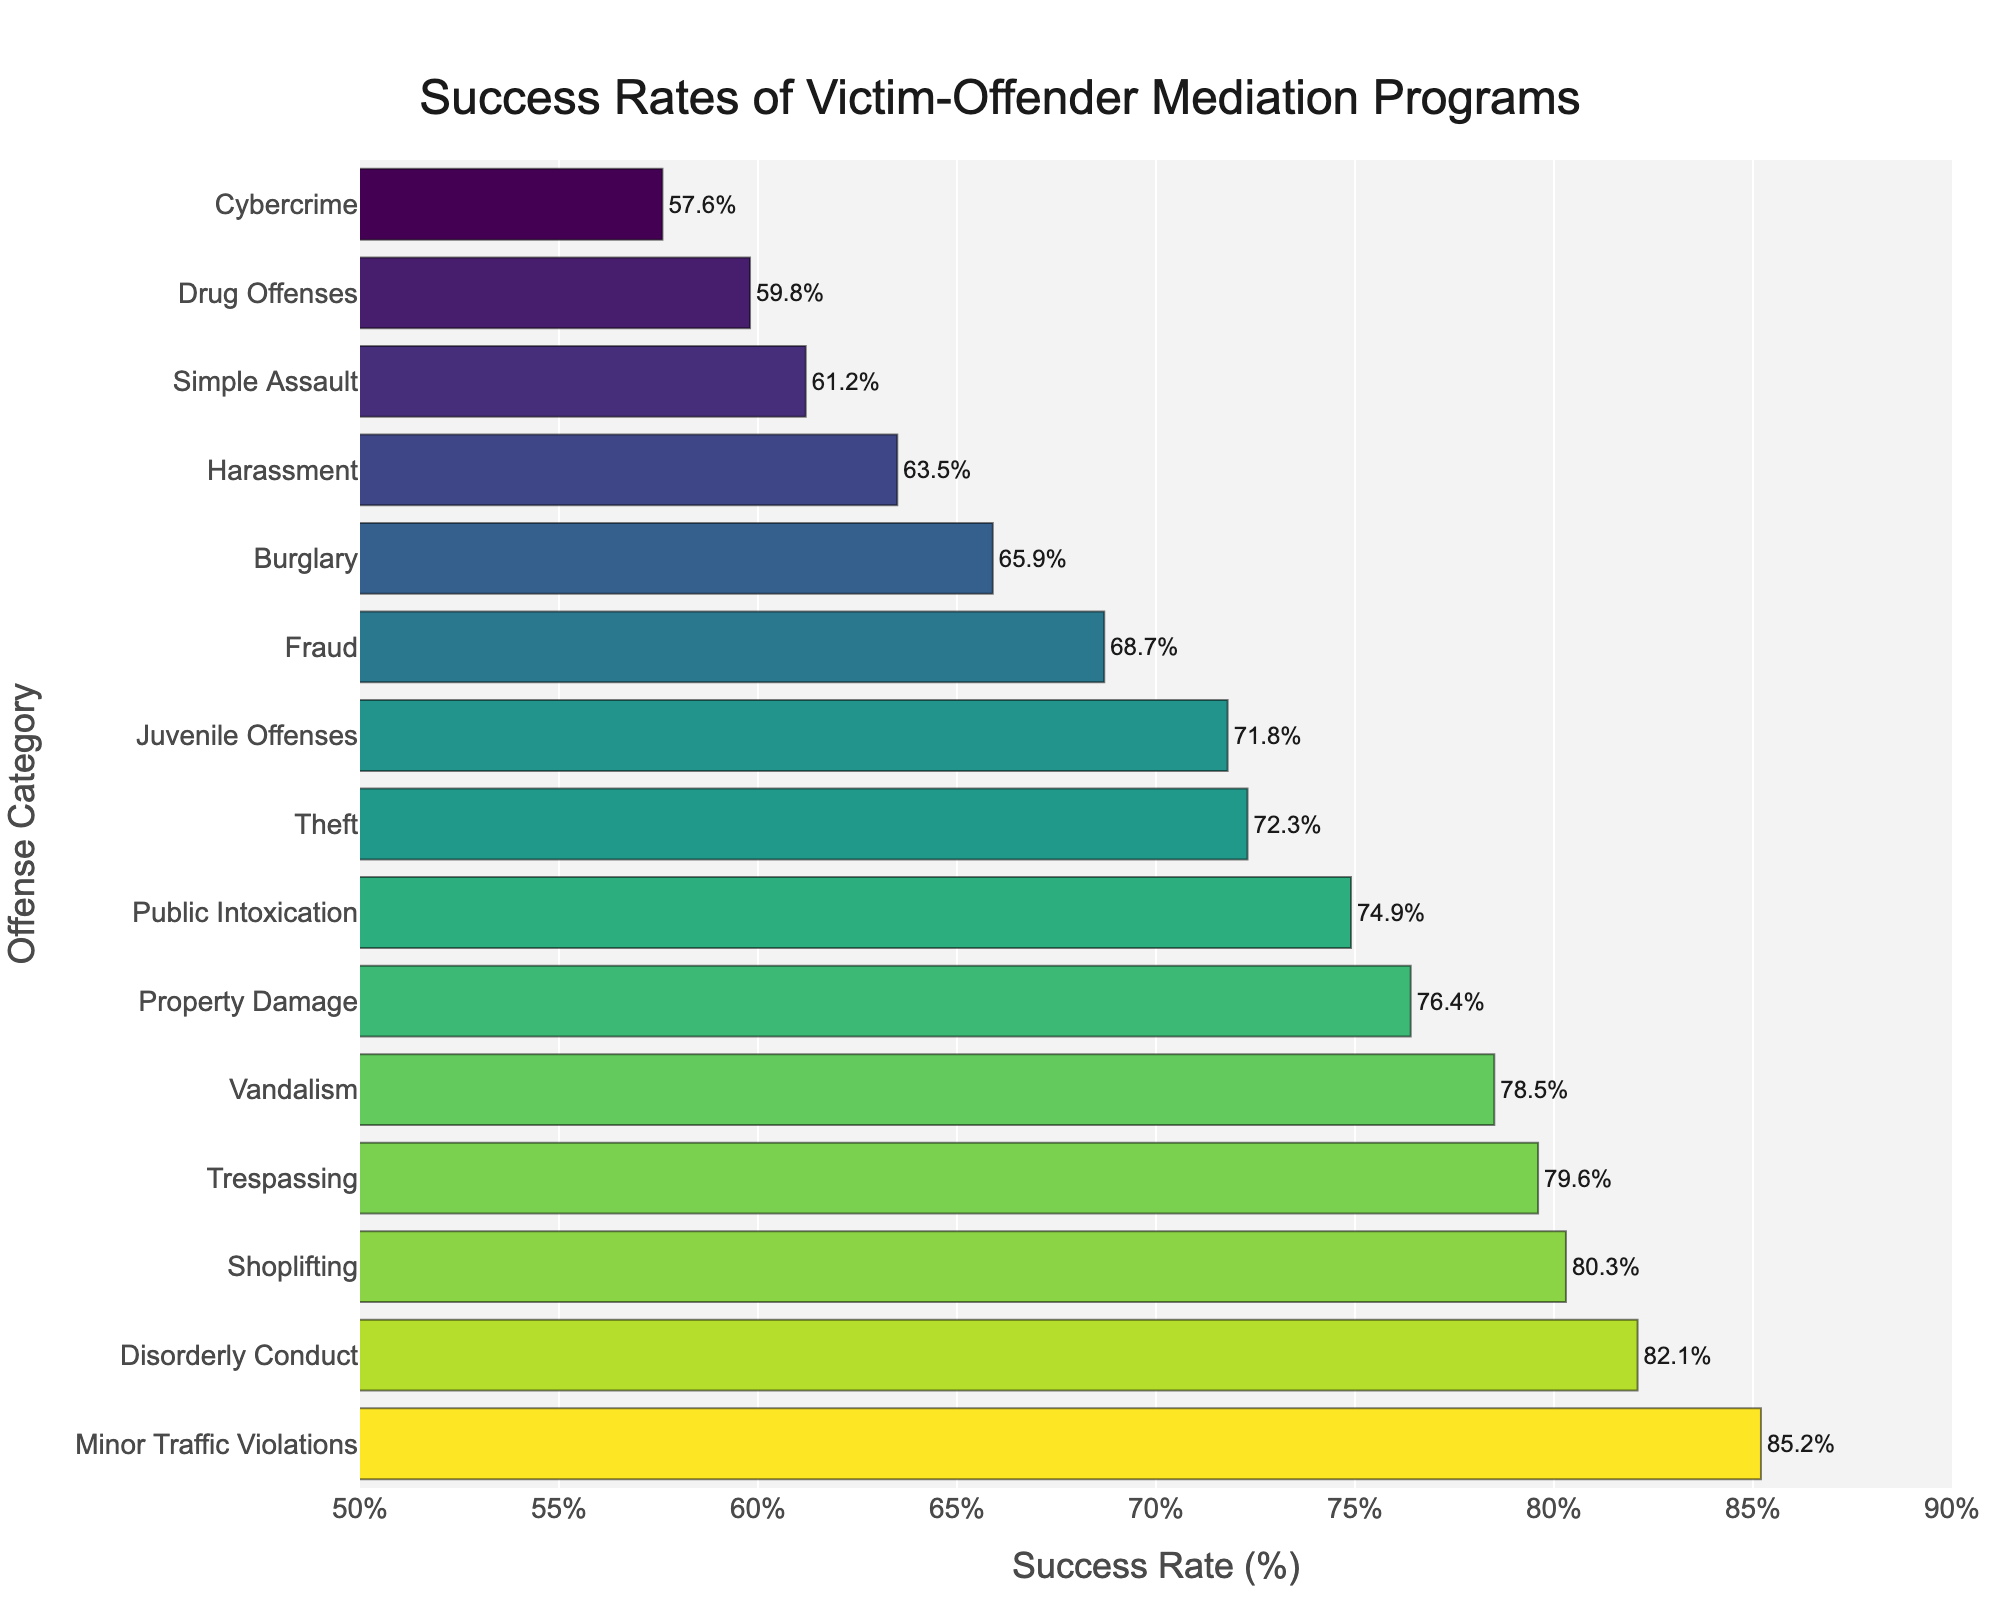Which offense category has the highest success rate in victim-offender mediation programs? The offense category with the highest success rate will be the one with the bar extending the furthest to the right on the x-axis.
Answer: Minor Traffic Violations Which offense category has the lowest success rate? The offense category with the lowest success rate will be the one with the shortest bar on the x-axis.
Answer: Cybercrime What is the difference in success rate between Minor Traffic Violations and Cybercrime? Subtract the success rate of Cybercrime from the success rate of Minor Traffic Violations: 85.2% - 57.6%.
Answer: 27.6% Which offense categories have a success rate higher than 75%? Look for all offense categories whose bars extend past the 75% mark on the x-axis.
Answer: Vandalism, Property Damage, Disorderly Conduct, Trespassing, Shoplifting, Minor Traffic Violations How does the success rate of Burglary compare to that of Theft? Compare the lengths of the bars for Burglary and Theft on the x-axis. Burglary has a success rate of 65.9% and Theft has a success rate of 72.3%, so Theft's bar is longer.
Answer: Theft is higher What's the average success rate of Vandalism, Theft, and Burglary? Add the success rates of Vandalism (78.5%), Theft (72.3%), and Burglary (65.9%) and divide by 3: (78.5 + 72.3 + 65.9) / 3.
Answer: 72.23% What is the range of success rates across all offense categories? Subtract the lowest success rate (Cybercrime: 57.6%) from the highest success rate (Minor Traffic Violations: 85.2%).
Answer: 27.6% Which categories have success rates between 60% and 70%? Look for bars that fall within the range of 60% to 70% on the x-axis.
Answer: Burglary, Harassment, Fraud, Simple Assault Is the success rate of Simple Assault greater than that of Drug Offenses by more than 1%? Subtract the success rate of Drug Offenses from Simple Assault: 61.2% - 59.8% = 1.4%. Since 1.4% > 1%, the answer is yes.
Answer: Yes 